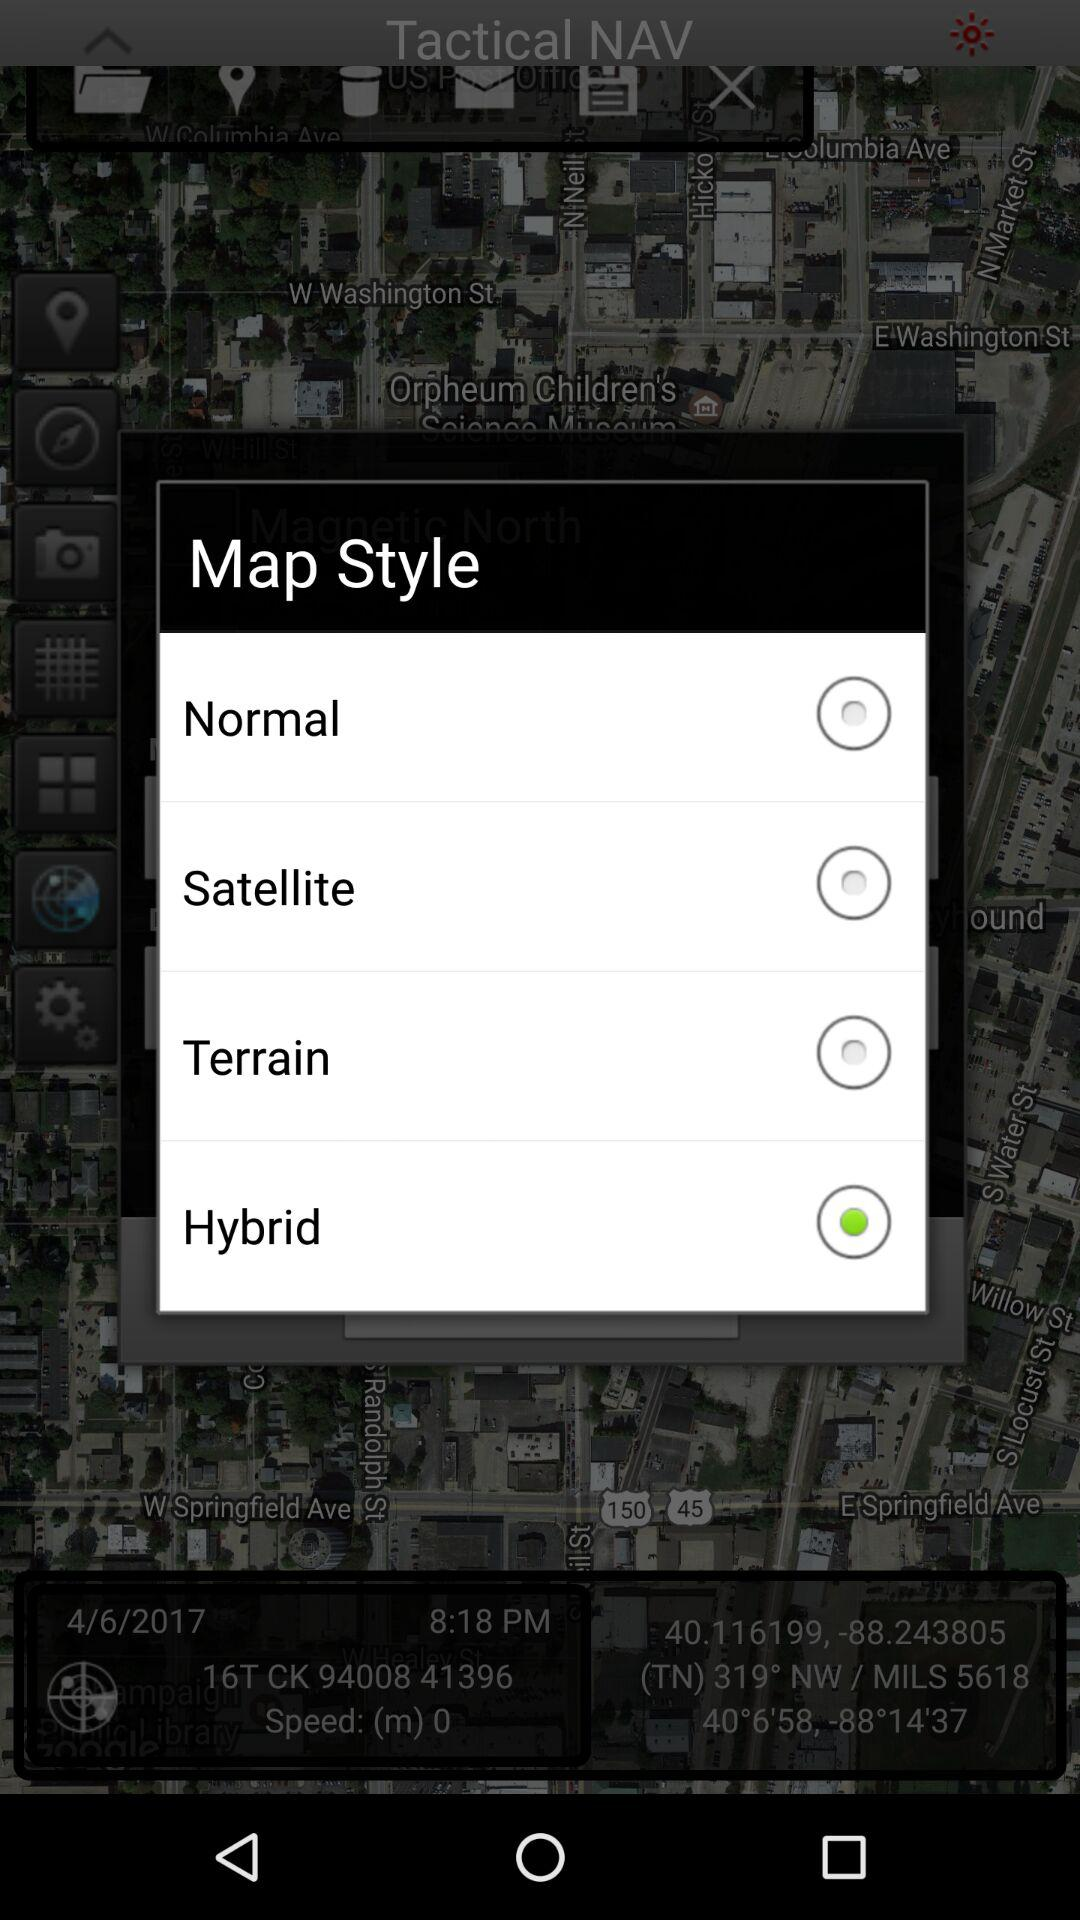What is the given date? The given date is April 6, 2017. 